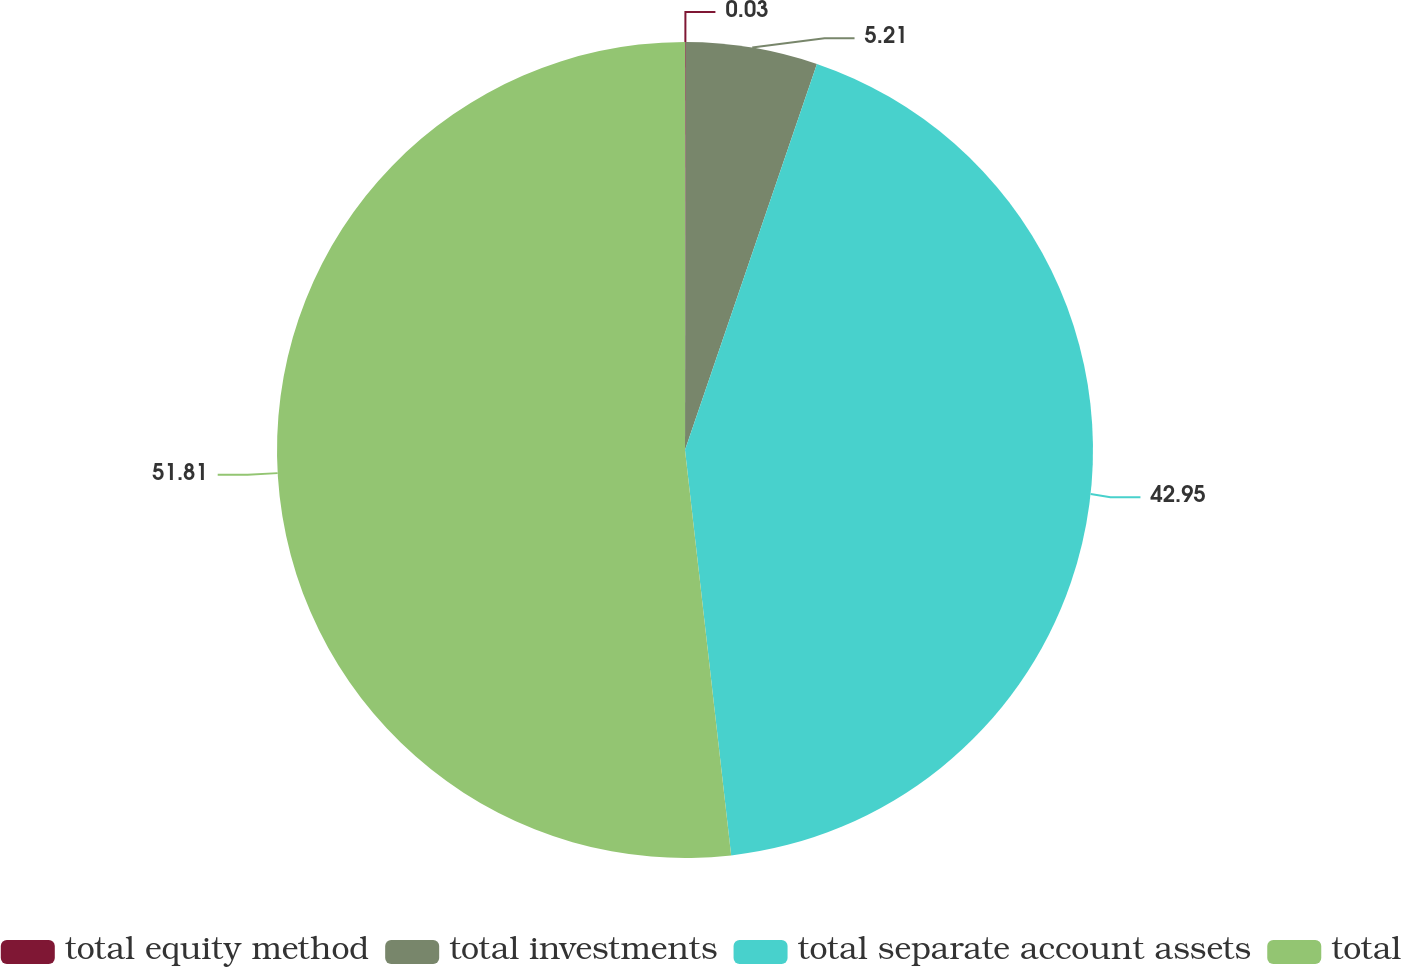<chart> <loc_0><loc_0><loc_500><loc_500><pie_chart><fcel>total equity method<fcel>total investments<fcel>total separate account assets<fcel>total<nl><fcel>0.03%<fcel>5.21%<fcel>42.95%<fcel>51.8%<nl></chart> 